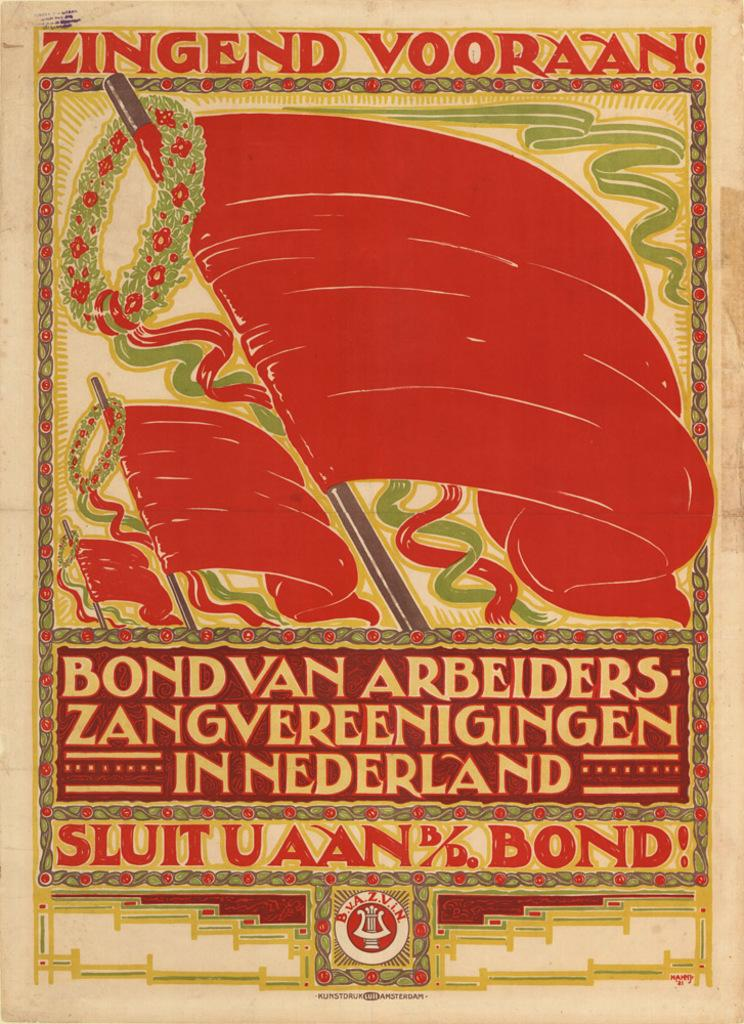<image>
Create a compact narrative representing the image presented. A poster is highlighted by the phrase "Zingend Vooran!" 